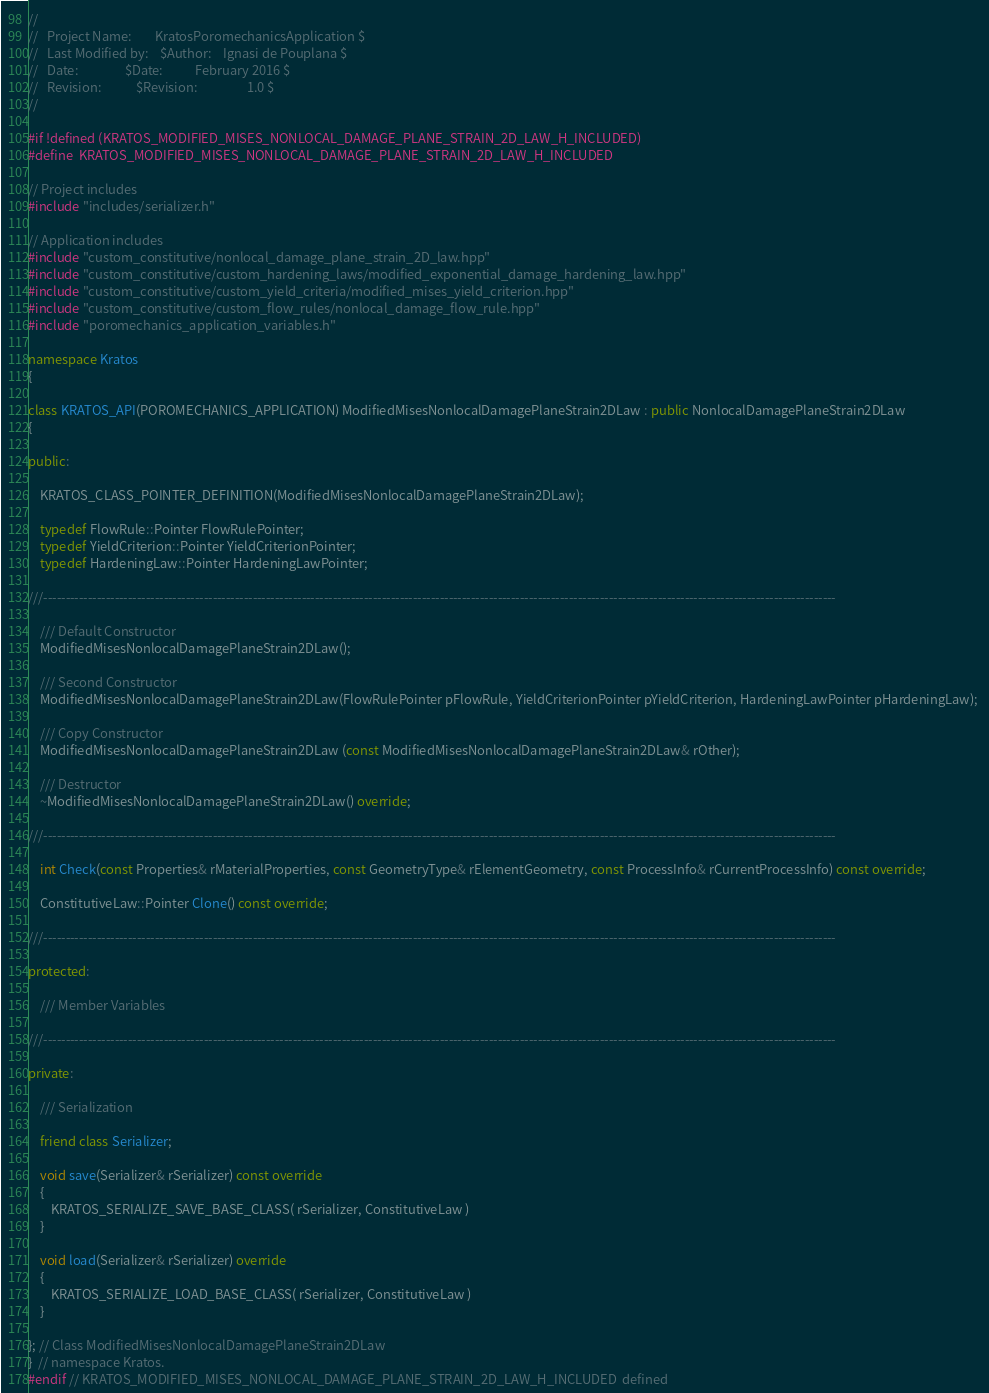Convert code to text. <code><loc_0><loc_0><loc_500><loc_500><_C++_>//   
//   Project Name:        KratosPoromechanicsApplication $
//   Last Modified by:    $Author:    Ignasi de Pouplana $
//   Date:                $Date:           February 2016 $
//   Revision:            $Revision:                 1.0 $
//

#if !defined (KRATOS_MODIFIED_MISES_NONLOCAL_DAMAGE_PLANE_STRAIN_2D_LAW_H_INCLUDED)
#define  KRATOS_MODIFIED_MISES_NONLOCAL_DAMAGE_PLANE_STRAIN_2D_LAW_H_INCLUDED

// Project includes
#include "includes/serializer.h"

// Application includes
#include "custom_constitutive/nonlocal_damage_plane_strain_2D_law.hpp"
#include "custom_constitutive/custom_hardening_laws/modified_exponential_damage_hardening_law.hpp"
#include "custom_constitutive/custom_yield_criteria/modified_mises_yield_criterion.hpp"
#include "custom_constitutive/custom_flow_rules/nonlocal_damage_flow_rule.hpp"
#include "poromechanics_application_variables.h"

namespace Kratos
{

class KRATOS_API(POROMECHANICS_APPLICATION) ModifiedMisesNonlocalDamagePlaneStrain2DLaw : public NonlocalDamagePlaneStrain2DLaw
{

public:

    KRATOS_CLASS_POINTER_DEFINITION(ModifiedMisesNonlocalDamagePlaneStrain2DLaw);

    typedef FlowRule::Pointer FlowRulePointer;
    typedef YieldCriterion::Pointer YieldCriterionPointer;
    typedef HardeningLaw::Pointer HardeningLawPointer;

///----------------------------------------------------------------------------------------------------------------------------------------------------------------------------------

    /// Default Constructor
    ModifiedMisesNonlocalDamagePlaneStrain2DLaw();
    
    /// Second Constructor
    ModifiedMisesNonlocalDamagePlaneStrain2DLaw(FlowRulePointer pFlowRule, YieldCriterionPointer pYieldCriterion, HardeningLawPointer pHardeningLaw); 
    
    /// Copy Constructor
    ModifiedMisesNonlocalDamagePlaneStrain2DLaw (const ModifiedMisesNonlocalDamagePlaneStrain2DLaw& rOther);

    /// Destructor
    ~ModifiedMisesNonlocalDamagePlaneStrain2DLaw() override;

///----------------------------------------------------------------------------------------------------------------------------------------------------------------------------------
    
    int Check(const Properties& rMaterialProperties, const GeometryType& rElementGeometry, const ProcessInfo& rCurrentProcessInfo) const override;
    
    ConstitutiveLaw::Pointer Clone() const override;

///----------------------------------------------------------------------------------------------------------------------------------------------------------------------------------

protected:

    /// Member Variables
        
///----------------------------------------------------------------------------------------------------------------------------------------------------------------------------------

private:
    
    /// Serialization
    
    friend class Serializer;

    void save(Serializer& rSerializer) const override
    {
        KRATOS_SERIALIZE_SAVE_BASE_CLASS( rSerializer, ConstitutiveLaw )
    }

    void load(Serializer& rSerializer) override
    {
        KRATOS_SERIALIZE_LOAD_BASE_CLASS( rSerializer, ConstitutiveLaw )
    }

}; // Class ModifiedMisesNonlocalDamagePlaneStrain2DLaw
}  // namespace Kratos.
#endif // KRATOS_MODIFIED_MISES_NONLOCAL_DAMAGE_PLANE_STRAIN_2D_LAW_H_INCLUDED  defined 
</code> 